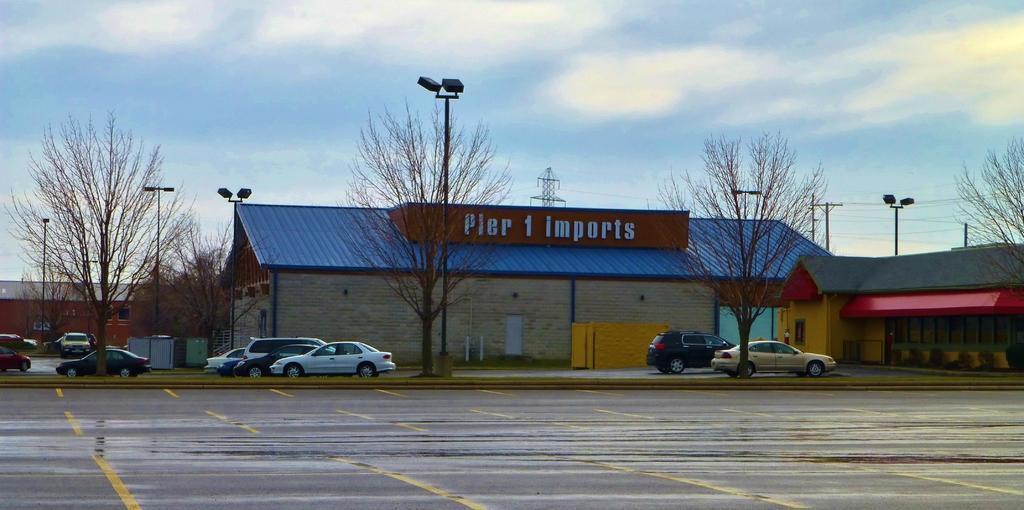Please provide a concise description of this image. In this image we can see a parking area. There are trees and light poles. Also there are vehicles. In the background there are buildings. Also there is sky with clouds. And there is an electric pole with wires. And there is a tower. 